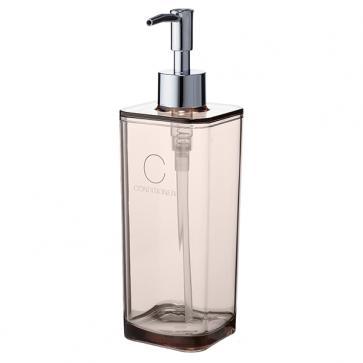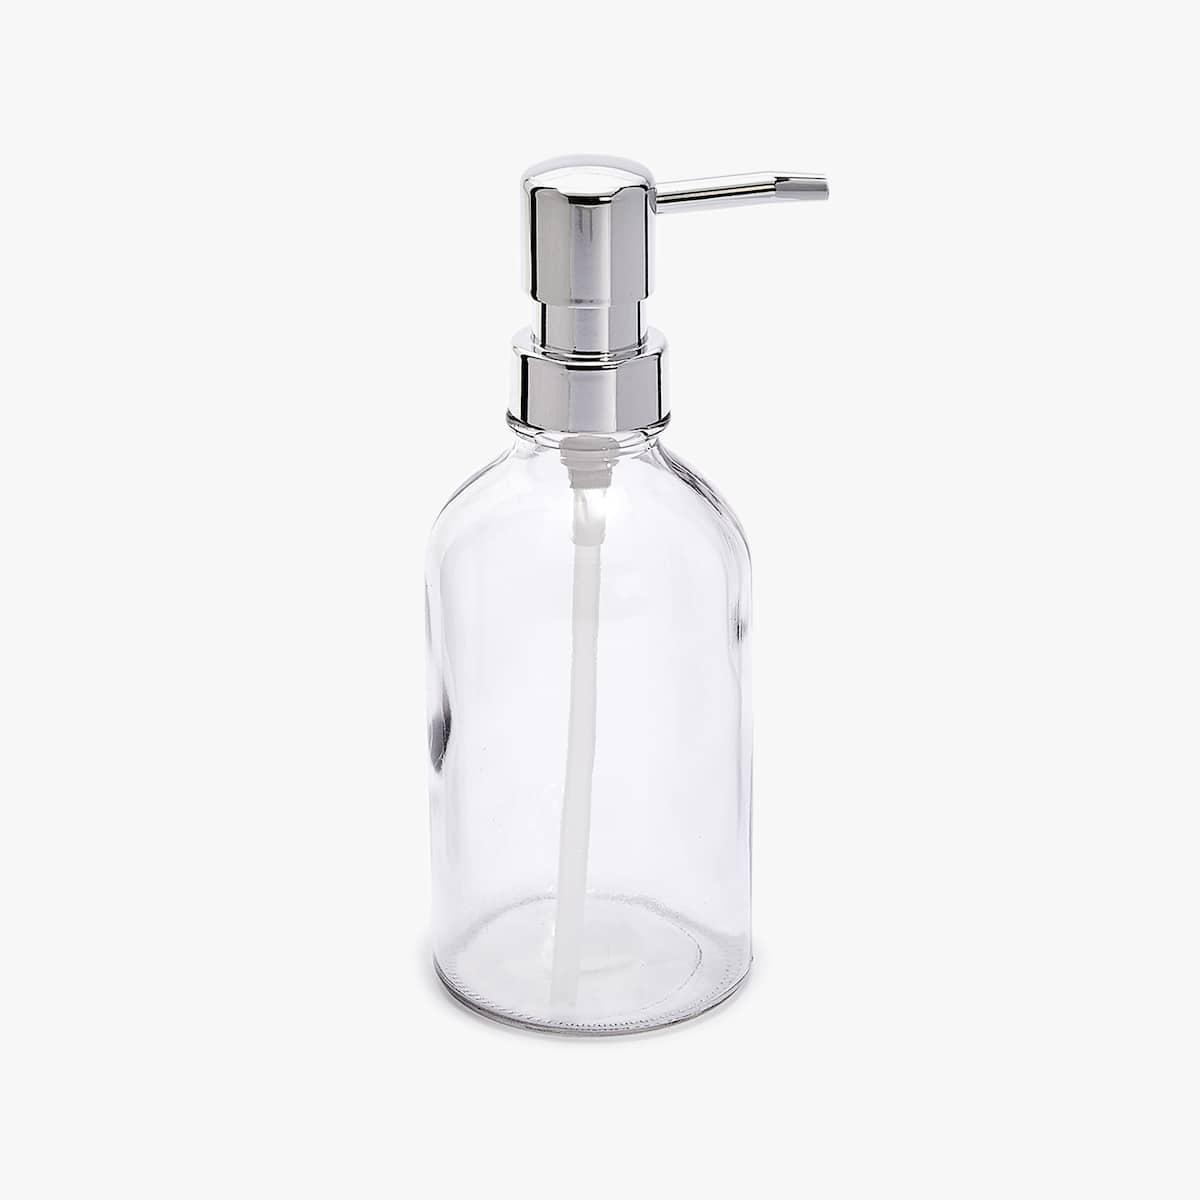The first image is the image on the left, the second image is the image on the right. Considering the images on both sides, is "The right image is an empty soap dispenser facing to the right." valid? Answer yes or no. Yes. The first image is the image on the left, the second image is the image on the right. Assess this claim about the two images: "The dispenser in both pictures is pointing toward the left.". Correct or not? Answer yes or no. No. 